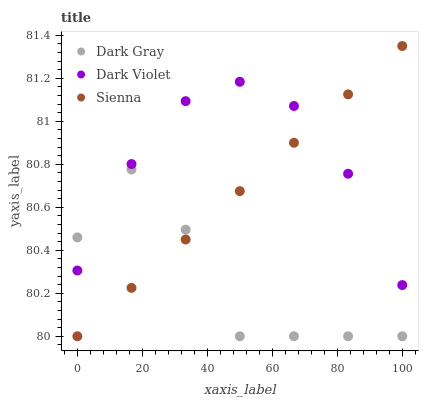Does Dark Gray have the minimum area under the curve?
Answer yes or no. Yes. Does Dark Violet have the maximum area under the curve?
Answer yes or no. Yes. Does Sienna have the minimum area under the curve?
Answer yes or no. No. Does Sienna have the maximum area under the curve?
Answer yes or no. No. Is Sienna the smoothest?
Answer yes or no. Yes. Is Dark Gray the roughest?
Answer yes or no. Yes. Is Dark Violet the smoothest?
Answer yes or no. No. Is Dark Violet the roughest?
Answer yes or no. No. Does Dark Gray have the lowest value?
Answer yes or no. Yes. Does Dark Violet have the lowest value?
Answer yes or no. No. Does Sienna have the highest value?
Answer yes or no. Yes. Does Dark Violet have the highest value?
Answer yes or no. No. Does Dark Gray intersect Dark Violet?
Answer yes or no. Yes. Is Dark Gray less than Dark Violet?
Answer yes or no. No. Is Dark Gray greater than Dark Violet?
Answer yes or no. No. 